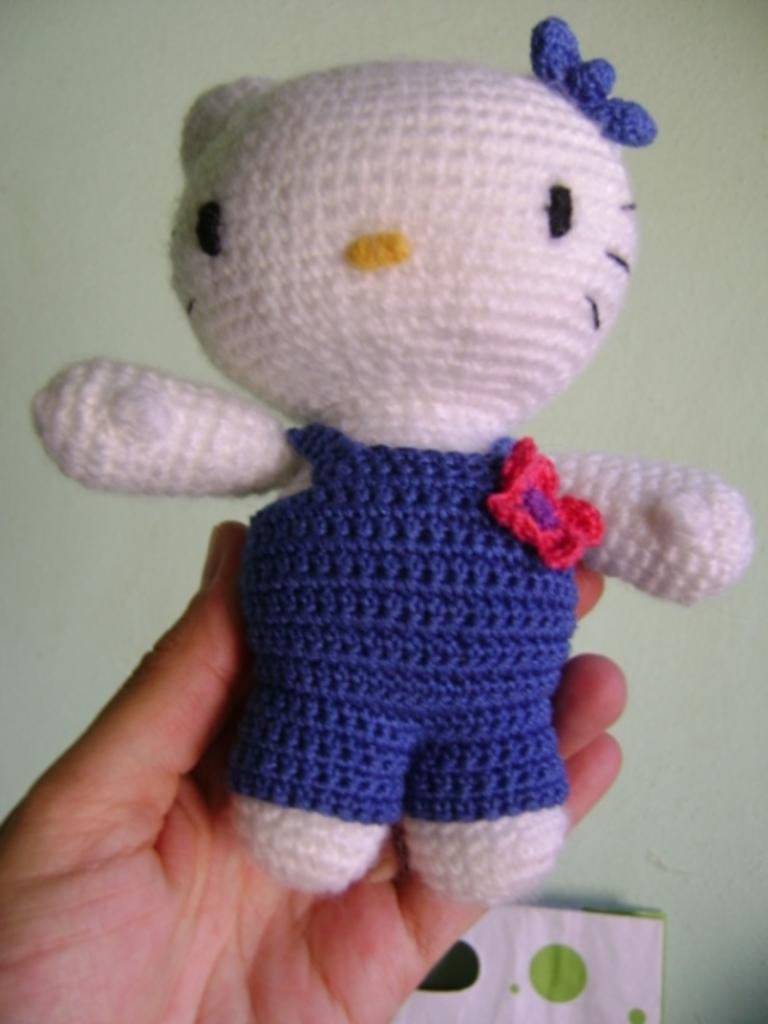What is the main subject of the image? The main subject of the image is a human hand. What is the hand holding in the image? The hand is holding a toy in the image. Can you describe the toy? The toy is blue and white in color. What can be seen in the background of the image? There is a wall and a paper in the background of the image. What type of sand can be seen in the image? There is no sand present in the image. What force is being applied to the toy in the image? The image does not provide information about any force being applied to the toy. 